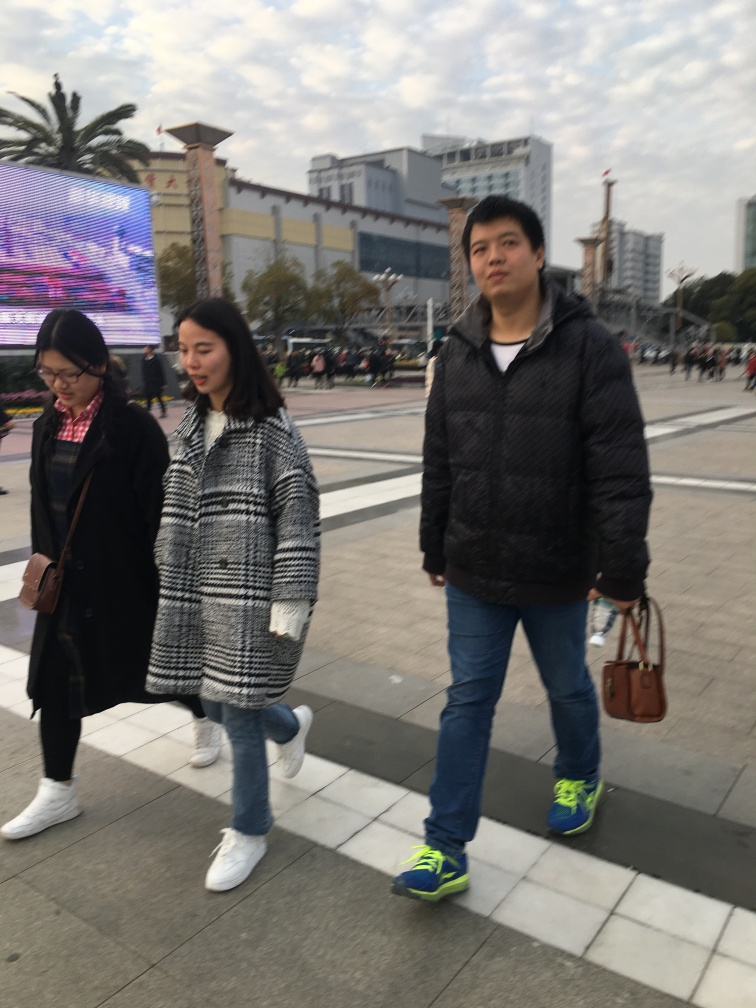Can you describe the style of clothing that the people in the image are wearing, and what it might say about the weather or season? The individuals in the image are dressed in layers, suggesting a cooler season, likely autumn or early spring. Their style is casual and functional, with the use of jackets and jeans, which implies that the weather is brisk but not severely cold. 